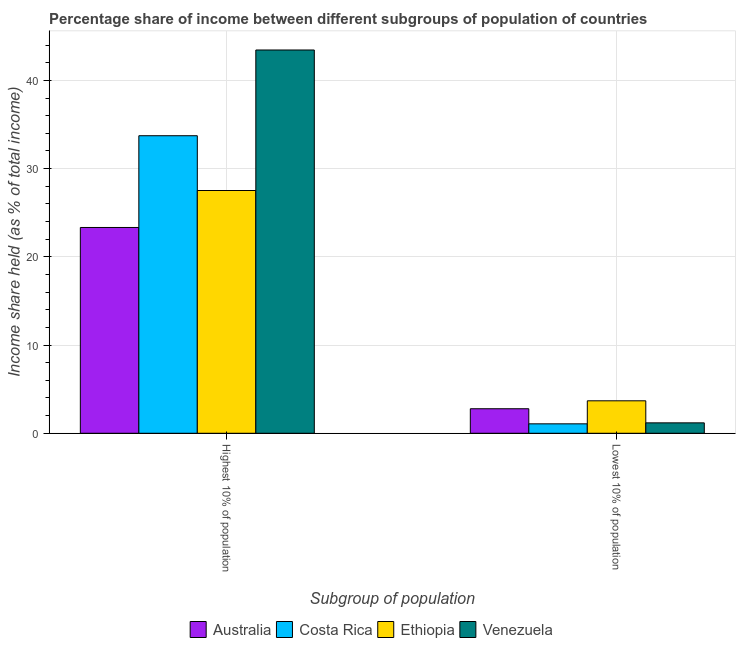How many different coloured bars are there?
Your answer should be very brief. 4. How many bars are there on the 2nd tick from the right?
Provide a short and direct response. 4. What is the label of the 2nd group of bars from the left?
Offer a very short reply. Lowest 10% of population. What is the income share held by highest 10% of the population in Australia?
Provide a succinct answer. 23.33. Across all countries, what is the maximum income share held by lowest 10% of the population?
Give a very brief answer. 3.68. Across all countries, what is the minimum income share held by highest 10% of the population?
Ensure brevity in your answer.  23.33. In which country was the income share held by highest 10% of the population maximum?
Make the answer very short. Venezuela. In which country was the income share held by highest 10% of the population minimum?
Provide a short and direct response. Australia. What is the total income share held by lowest 10% of the population in the graph?
Make the answer very short. 8.71. What is the difference between the income share held by lowest 10% of the population in Ethiopia and that in Australia?
Ensure brevity in your answer.  0.9. What is the difference between the income share held by highest 10% of the population in Australia and the income share held by lowest 10% of the population in Ethiopia?
Make the answer very short. 19.65. What is the average income share held by highest 10% of the population per country?
Provide a short and direct response. 32.01. What is the difference between the income share held by highest 10% of the population and income share held by lowest 10% of the population in Venezuela?
Your response must be concise. 42.27. In how many countries, is the income share held by lowest 10% of the population greater than 4 %?
Provide a succinct answer. 0. What is the ratio of the income share held by lowest 10% of the population in Costa Rica to that in Australia?
Your answer should be very brief. 0.38. What does the 2nd bar from the left in Highest 10% of population represents?
Provide a succinct answer. Costa Rica. What does the 1st bar from the right in Highest 10% of population represents?
Give a very brief answer. Venezuela. How many bars are there?
Give a very brief answer. 8. Are all the bars in the graph horizontal?
Ensure brevity in your answer.  No. How many countries are there in the graph?
Your answer should be very brief. 4. What is the difference between two consecutive major ticks on the Y-axis?
Offer a very short reply. 10. Are the values on the major ticks of Y-axis written in scientific E-notation?
Give a very brief answer. No. Does the graph contain any zero values?
Ensure brevity in your answer.  No. How many legend labels are there?
Ensure brevity in your answer.  4. What is the title of the graph?
Ensure brevity in your answer.  Percentage share of income between different subgroups of population of countries. What is the label or title of the X-axis?
Offer a very short reply. Subgroup of population. What is the label or title of the Y-axis?
Provide a succinct answer. Income share held (as % of total income). What is the Income share held (as % of total income) of Australia in Highest 10% of population?
Your answer should be compact. 23.33. What is the Income share held (as % of total income) in Costa Rica in Highest 10% of population?
Keep it short and to the point. 33.73. What is the Income share held (as % of total income) in Ethiopia in Highest 10% of population?
Your response must be concise. 27.52. What is the Income share held (as % of total income) in Venezuela in Highest 10% of population?
Your response must be concise. 43.45. What is the Income share held (as % of total income) in Australia in Lowest 10% of population?
Offer a terse response. 2.78. What is the Income share held (as % of total income) of Costa Rica in Lowest 10% of population?
Keep it short and to the point. 1.07. What is the Income share held (as % of total income) of Ethiopia in Lowest 10% of population?
Keep it short and to the point. 3.68. What is the Income share held (as % of total income) in Venezuela in Lowest 10% of population?
Ensure brevity in your answer.  1.18. Across all Subgroup of population, what is the maximum Income share held (as % of total income) of Australia?
Ensure brevity in your answer.  23.33. Across all Subgroup of population, what is the maximum Income share held (as % of total income) in Costa Rica?
Provide a succinct answer. 33.73. Across all Subgroup of population, what is the maximum Income share held (as % of total income) in Ethiopia?
Your answer should be very brief. 27.52. Across all Subgroup of population, what is the maximum Income share held (as % of total income) of Venezuela?
Your answer should be compact. 43.45. Across all Subgroup of population, what is the minimum Income share held (as % of total income) of Australia?
Provide a succinct answer. 2.78. Across all Subgroup of population, what is the minimum Income share held (as % of total income) in Costa Rica?
Make the answer very short. 1.07. Across all Subgroup of population, what is the minimum Income share held (as % of total income) in Ethiopia?
Your answer should be compact. 3.68. Across all Subgroup of population, what is the minimum Income share held (as % of total income) of Venezuela?
Keep it short and to the point. 1.18. What is the total Income share held (as % of total income) of Australia in the graph?
Make the answer very short. 26.11. What is the total Income share held (as % of total income) in Costa Rica in the graph?
Offer a very short reply. 34.8. What is the total Income share held (as % of total income) in Ethiopia in the graph?
Ensure brevity in your answer.  31.2. What is the total Income share held (as % of total income) of Venezuela in the graph?
Your answer should be compact. 44.63. What is the difference between the Income share held (as % of total income) of Australia in Highest 10% of population and that in Lowest 10% of population?
Offer a very short reply. 20.55. What is the difference between the Income share held (as % of total income) in Costa Rica in Highest 10% of population and that in Lowest 10% of population?
Your answer should be compact. 32.66. What is the difference between the Income share held (as % of total income) in Ethiopia in Highest 10% of population and that in Lowest 10% of population?
Offer a very short reply. 23.84. What is the difference between the Income share held (as % of total income) in Venezuela in Highest 10% of population and that in Lowest 10% of population?
Provide a short and direct response. 42.27. What is the difference between the Income share held (as % of total income) of Australia in Highest 10% of population and the Income share held (as % of total income) of Costa Rica in Lowest 10% of population?
Give a very brief answer. 22.26. What is the difference between the Income share held (as % of total income) of Australia in Highest 10% of population and the Income share held (as % of total income) of Ethiopia in Lowest 10% of population?
Your response must be concise. 19.65. What is the difference between the Income share held (as % of total income) of Australia in Highest 10% of population and the Income share held (as % of total income) of Venezuela in Lowest 10% of population?
Offer a terse response. 22.15. What is the difference between the Income share held (as % of total income) in Costa Rica in Highest 10% of population and the Income share held (as % of total income) in Ethiopia in Lowest 10% of population?
Provide a succinct answer. 30.05. What is the difference between the Income share held (as % of total income) in Costa Rica in Highest 10% of population and the Income share held (as % of total income) in Venezuela in Lowest 10% of population?
Provide a short and direct response. 32.55. What is the difference between the Income share held (as % of total income) of Ethiopia in Highest 10% of population and the Income share held (as % of total income) of Venezuela in Lowest 10% of population?
Provide a succinct answer. 26.34. What is the average Income share held (as % of total income) in Australia per Subgroup of population?
Your response must be concise. 13.05. What is the average Income share held (as % of total income) in Costa Rica per Subgroup of population?
Give a very brief answer. 17.4. What is the average Income share held (as % of total income) in Ethiopia per Subgroup of population?
Provide a short and direct response. 15.6. What is the average Income share held (as % of total income) in Venezuela per Subgroup of population?
Offer a terse response. 22.32. What is the difference between the Income share held (as % of total income) of Australia and Income share held (as % of total income) of Costa Rica in Highest 10% of population?
Make the answer very short. -10.4. What is the difference between the Income share held (as % of total income) of Australia and Income share held (as % of total income) of Ethiopia in Highest 10% of population?
Provide a short and direct response. -4.19. What is the difference between the Income share held (as % of total income) of Australia and Income share held (as % of total income) of Venezuela in Highest 10% of population?
Your response must be concise. -20.12. What is the difference between the Income share held (as % of total income) in Costa Rica and Income share held (as % of total income) in Ethiopia in Highest 10% of population?
Your response must be concise. 6.21. What is the difference between the Income share held (as % of total income) of Costa Rica and Income share held (as % of total income) of Venezuela in Highest 10% of population?
Keep it short and to the point. -9.72. What is the difference between the Income share held (as % of total income) of Ethiopia and Income share held (as % of total income) of Venezuela in Highest 10% of population?
Your answer should be very brief. -15.93. What is the difference between the Income share held (as % of total income) of Australia and Income share held (as % of total income) of Costa Rica in Lowest 10% of population?
Your response must be concise. 1.71. What is the difference between the Income share held (as % of total income) in Costa Rica and Income share held (as % of total income) in Ethiopia in Lowest 10% of population?
Offer a very short reply. -2.61. What is the difference between the Income share held (as % of total income) in Costa Rica and Income share held (as % of total income) in Venezuela in Lowest 10% of population?
Give a very brief answer. -0.11. What is the ratio of the Income share held (as % of total income) in Australia in Highest 10% of population to that in Lowest 10% of population?
Make the answer very short. 8.39. What is the ratio of the Income share held (as % of total income) in Costa Rica in Highest 10% of population to that in Lowest 10% of population?
Give a very brief answer. 31.52. What is the ratio of the Income share held (as % of total income) in Ethiopia in Highest 10% of population to that in Lowest 10% of population?
Ensure brevity in your answer.  7.48. What is the ratio of the Income share held (as % of total income) in Venezuela in Highest 10% of population to that in Lowest 10% of population?
Your answer should be very brief. 36.82. What is the difference between the highest and the second highest Income share held (as % of total income) of Australia?
Provide a short and direct response. 20.55. What is the difference between the highest and the second highest Income share held (as % of total income) in Costa Rica?
Give a very brief answer. 32.66. What is the difference between the highest and the second highest Income share held (as % of total income) in Ethiopia?
Offer a terse response. 23.84. What is the difference between the highest and the second highest Income share held (as % of total income) in Venezuela?
Offer a terse response. 42.27. What is the difference between the highest and the lowest Income share held (as % of total income) in Australia?
Keep it short and to the point. 20.55. What is the difference between the highest and the lowest Income share held (as % of total income) of Costa Rica?
Your answer should be compact. 32.66. What is the difference between the highest and the lowest Income share held (as % of total income) in Ethiopia?
Your answer should be compact. 23.84. What is the difference between the highest and the lowest Income share held (as % of total income) of Venezuela?
Provide a short and direct response. 42.27. 